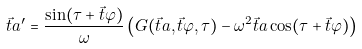Convert formula to latex. <formula><loc_0><loc_0><loc_500><loc_500>\vec { t } { a } ^ { \prime } = \frac { \sin ( \tau + \vec { t } { \varphi } ) } { \omega } \left ( G ( \vec { t } { a } , \vec { t } { \varphi } , \tau ) - \omega ^ { 2 } \vec { t } { a } \cos ( \tau + \vec { t } { \varphi } ) \right )</formula> 